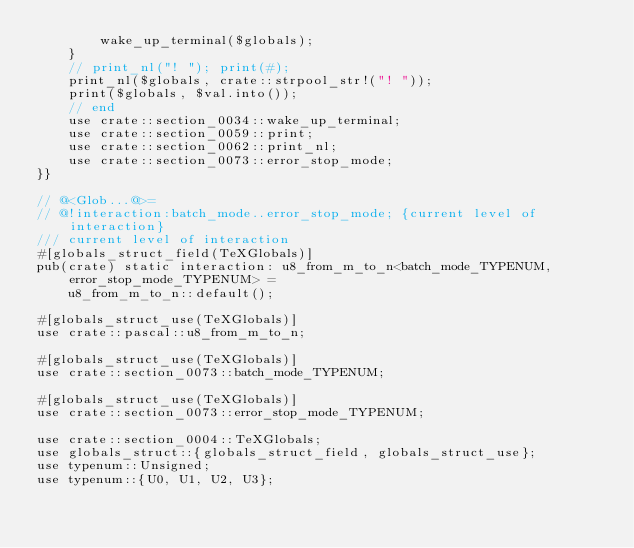Convert code to text. <code><loc_0><loc_0><loc_500><loc_500><_Rust_>        wake_up_terminal($globals);
    }
    // print_nl("! "); print(#);
    print_nl($globals, crate::strpool_str!("! "));
    print($globals, $val.into());
    // end
    use crate::section_0034::wake_up_terminal;
    use crate::section_0059::print;
    use crate::section_0062::print_nl;
    use crate::section_0073::error_stop_mode;
}}

// @<Glob...@>=
// @!interaction:batch_mode..error_stop_mode; {current level of interaction}
/// current level of interaction
#[globals_struct_field(TeXGlobals)]
pub(crate) static interaction: u8_from_m_to_n<batch_mode_TYPENUM, error_stop_mode_TYPENUM> =
    u8_from_m_to_n::default();

#[globals_struct_use(TeXGlobals)]
use crate::pascal::u8_from_m_to_n;

#[globals_struct_use(TeXGlobals)]
use crate::section_0073::batch_mode_TYPENUM;

#[globals_struct_use(TeXGlobals)]
use crate::section_0073::error_stop_mode_TYPENUM;

use crate::section_0004::TeXGlobals;
use globals_struct::{globals_struct_field, globals_struct_use};
use typenum::Unsigned;
use typenum::{U0, U1, U2, U3};
</code> 